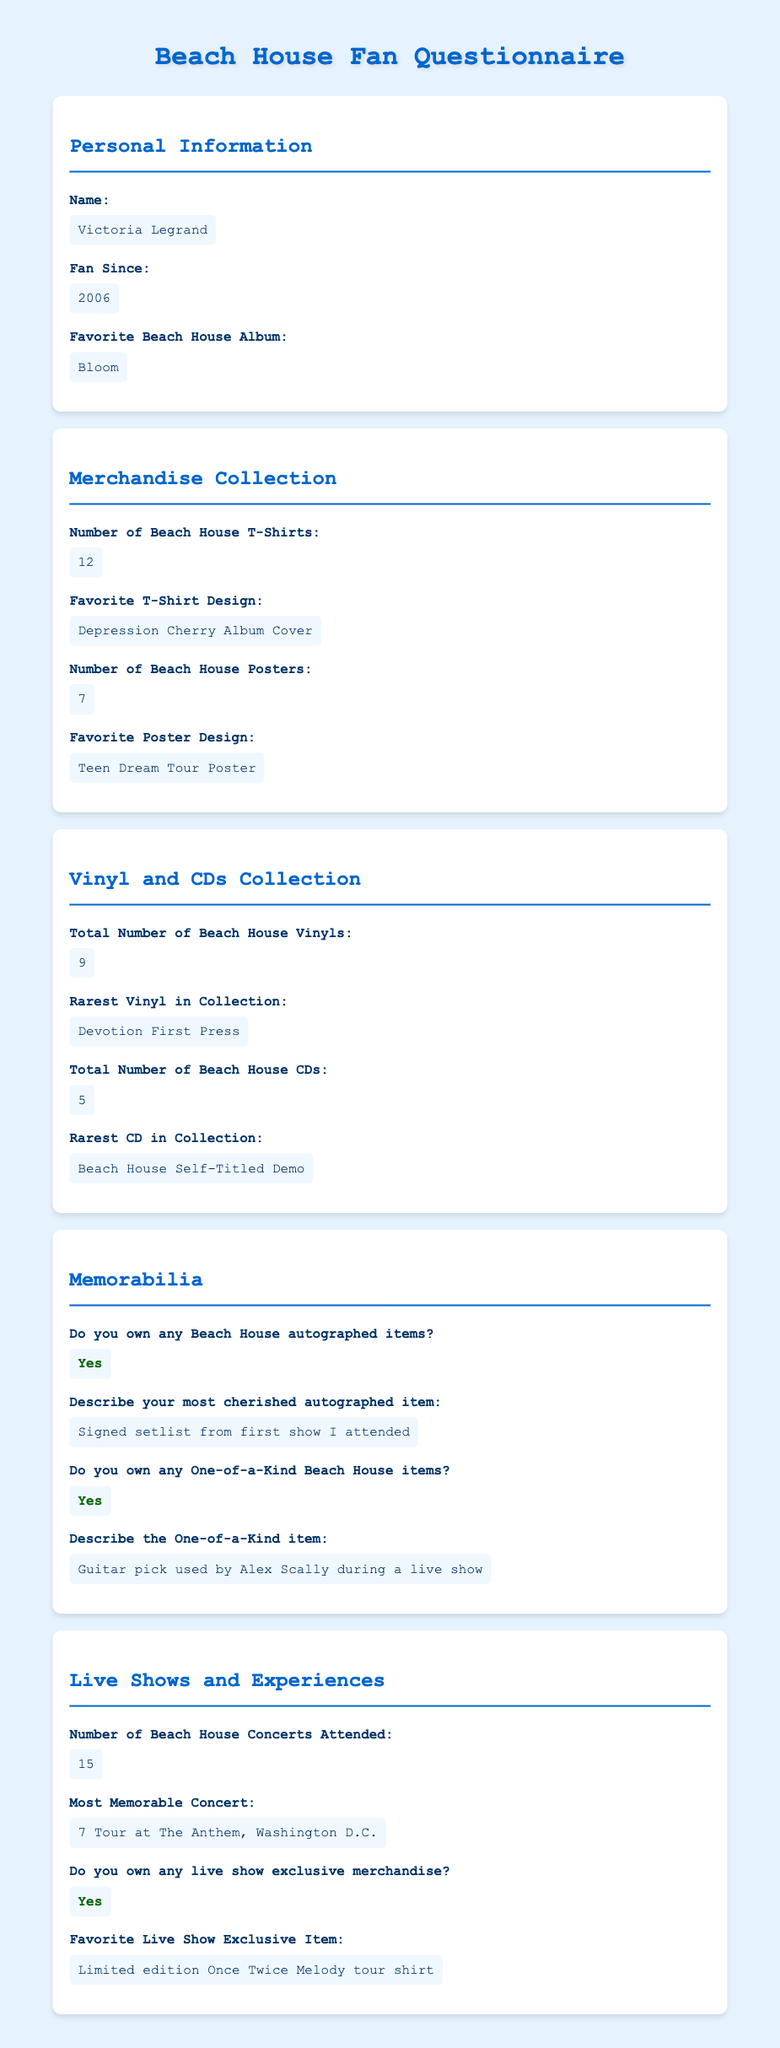What is the name of the fan? The name of the fan is provided in the personal information section of the document.
Answer: Victoria Legrand How many Beach House T-Shirts does the fan own? The number of T-Shirts is mentioned in the Merchandise Collection section of the document.
Answer: 12 What is the fan's favorite Beach House album? The fan's favorite album is mentioned in the personal information section of the document.
Answer: Bloom What is the rarest vinyl in the fan's collection? The rarest vinyl is specified in the Vinyl and CDs Collection section of the document.
Answer: Devotion First Press What is the total number of Beach House CDs owned by the fan? The total number of CDs is provided in the Vinyl and CDs Collection section of the document.
Answer: 5 What is the favorite poster design? The favorite poster design is mentioned in the Merchandise Collection section of the document.
Answer: Teen Dream Tour Poster How many concerts has the fan attended? The number of concerts attended is found in the Live Shows and Experiences section of the document.
Answer: 15 Does the fan own any one-of-a-kind Beach House items? This is a yes or no question found in the Memorabilia section of the document.
Answer: Yes Describe the most cherished autographed item. The most cherished autographed item is detailed in the Memorabilia section of the document.
Answer: Signed setlist from first show I attended What is the favorite live show exclusive item? The favorite exclusive item is noted in the Live Shows and Experiences section of the document.
Answer: Limited edition Once Twice Melody tour shirt 